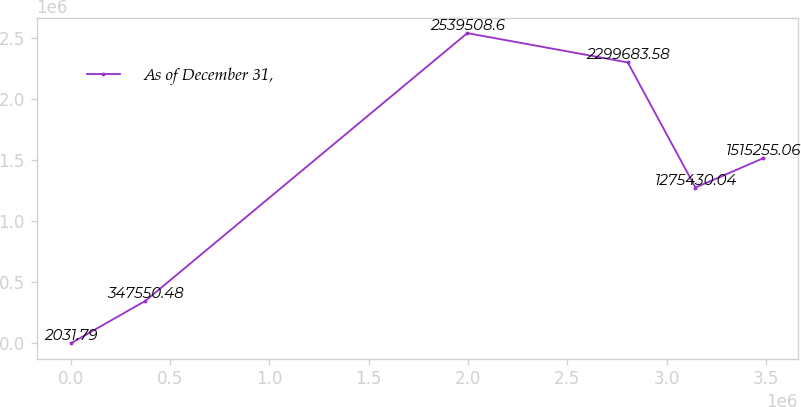Convert chart. <chart><loc_0><loc_0><loc_500><loc_500><line_chart><ecel><fcel>As of December 31,<nl><fcel>2217.64<fcel>2031.79<nl><fcel>375607<fcel>347550<nl><fcel>1.99632e+06<fcel>2.53951e+06<nl><fcel>2.80437e+06<fcel>2.29968e+06<nl><fcel>3.14521e+06<fcel>1.27543e+06<nl><fcel>3.48605e+06<fcel>1.51526e+06<nl></chart> 